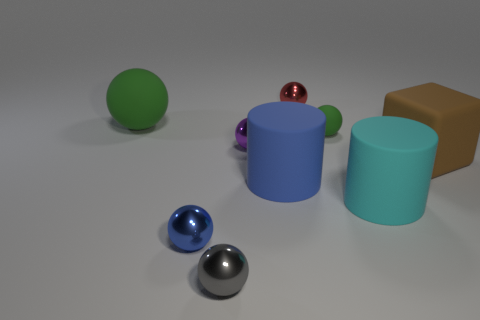Subtract 2 balls. How many balls are left? 4 Subtract all large green rubber spheres. How many spheres are left? 5 Subtract all gray spheres. How many spheres are left? 5 Subtract all gray balls. Subtract all purple blocks. How many balls are left? 5 Add 1 gray things. How many objects exist? 10 Subtract all cylinders. How many objects are left? 7 Add 2 brown objects. How many brown objects exist? 3 Subtract 1 blue cylinders. How many objects are left? 8 Subtract all red spheres. Subtract all blue cylinders. How many objects are left? 7 Add 5 green rubber things. How many green rubber things are left? 7 